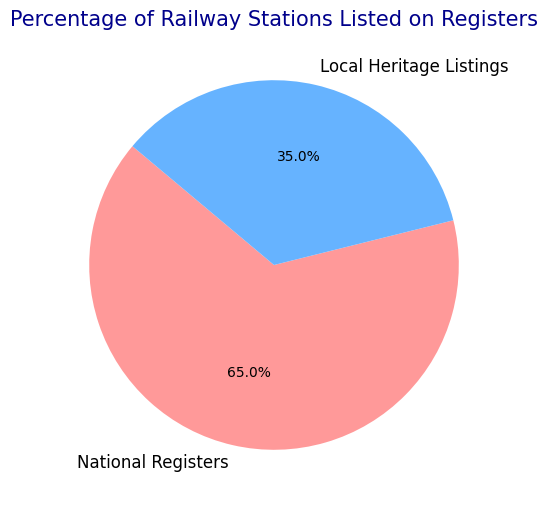What percentage of railway stations are listed on National Registers? The pie chart shows that the section for National Registers is labeled with a percentage. By looking at this label, we can directly find the percentage value.
Answer: 65% What is the difference in percentage points between railway stations listed on National Registers and Local Heritage Listings? To find the difference, subtract the percentage of Local Heritage Listings from the percentage of National Registers: 65% - 35% = 30%
Answer: 30% Which category has a smaller percentage of railway stations listed? The pie chart shows two categories with their respective percentages. The Local Heritage Listings section has 35%, which is smaller than the National Registers' 65%.
Answer: Local Heritage Listings How much more percentage of stations are listed on National Registers than on Local Heritage Listings? The percentage of stations listed on National Registers is 65%, and on Local Heritage Listings is 35%. The difference, 65% - 35%, gives us the additional percentage.
Answer: 30% Are a majority of railway stations listed on National Registers or Local Heritage Listings? A majority requires more than 50%. Since National Registers have 65% which is more than 50%, the majority is listed there.
Answer: National Registers If you combined the listings from both National Registers and Local Heritage Listings, what would be the total percentage? In a pie chart, the total always represents 100%. Adding up segments' percentages should sum to 100%. 65% + 35% = 100%.
Answer: 100% What is the visual indicator used to distinguish between the categories in the pie chart? The pie chart uses colors to distinguish between the categories. National Registers are shaded in a reddish color and Local Heritage Listings are shaded in a blueish color.
Answer: Colors By how many percentage points do National Register listings exceed Local Heritage Listings? National Registers listing is 65% and Local Heritage Listings is 35%. The excess can be calculated as 65% - 35%.
Answer: 30% If we were to invert the percentages, what would the pie chart show for National Registers and Local Heritage Listings? Inverting the percentages means swapping the values. So, National Registers would have 35% and Local Heritage Listings would have 65%.
Answer: National Registers: 35%, Local Heritage Listings: 65% 